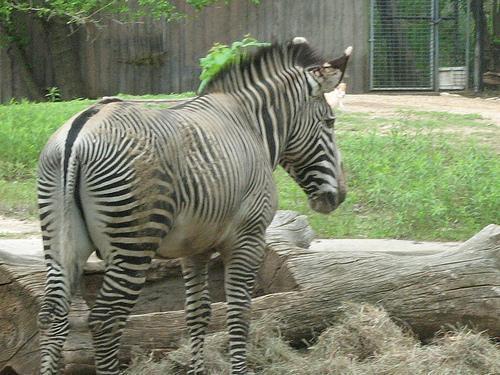How many more zebra are there other than this one?
Give a very brief answer. 0. 